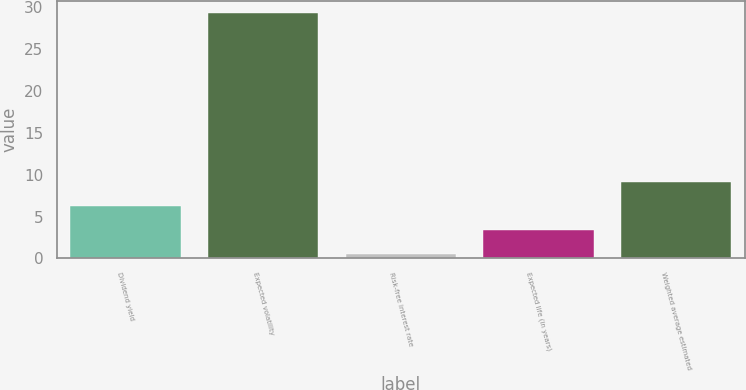<chart> <loc_0><loc_0><loc_500><loc_500><bar_chart><fcel>Dividend yield<fcel>Expected volatility<fcel>Risk-free interest rate<fcel>Expected life (in years)<fcel>Weighted average estimated<nl><fcel>6.23<fcel>29.3<fcel>0.47<fcel>3.35<fcel>9.11<nl></chart> 